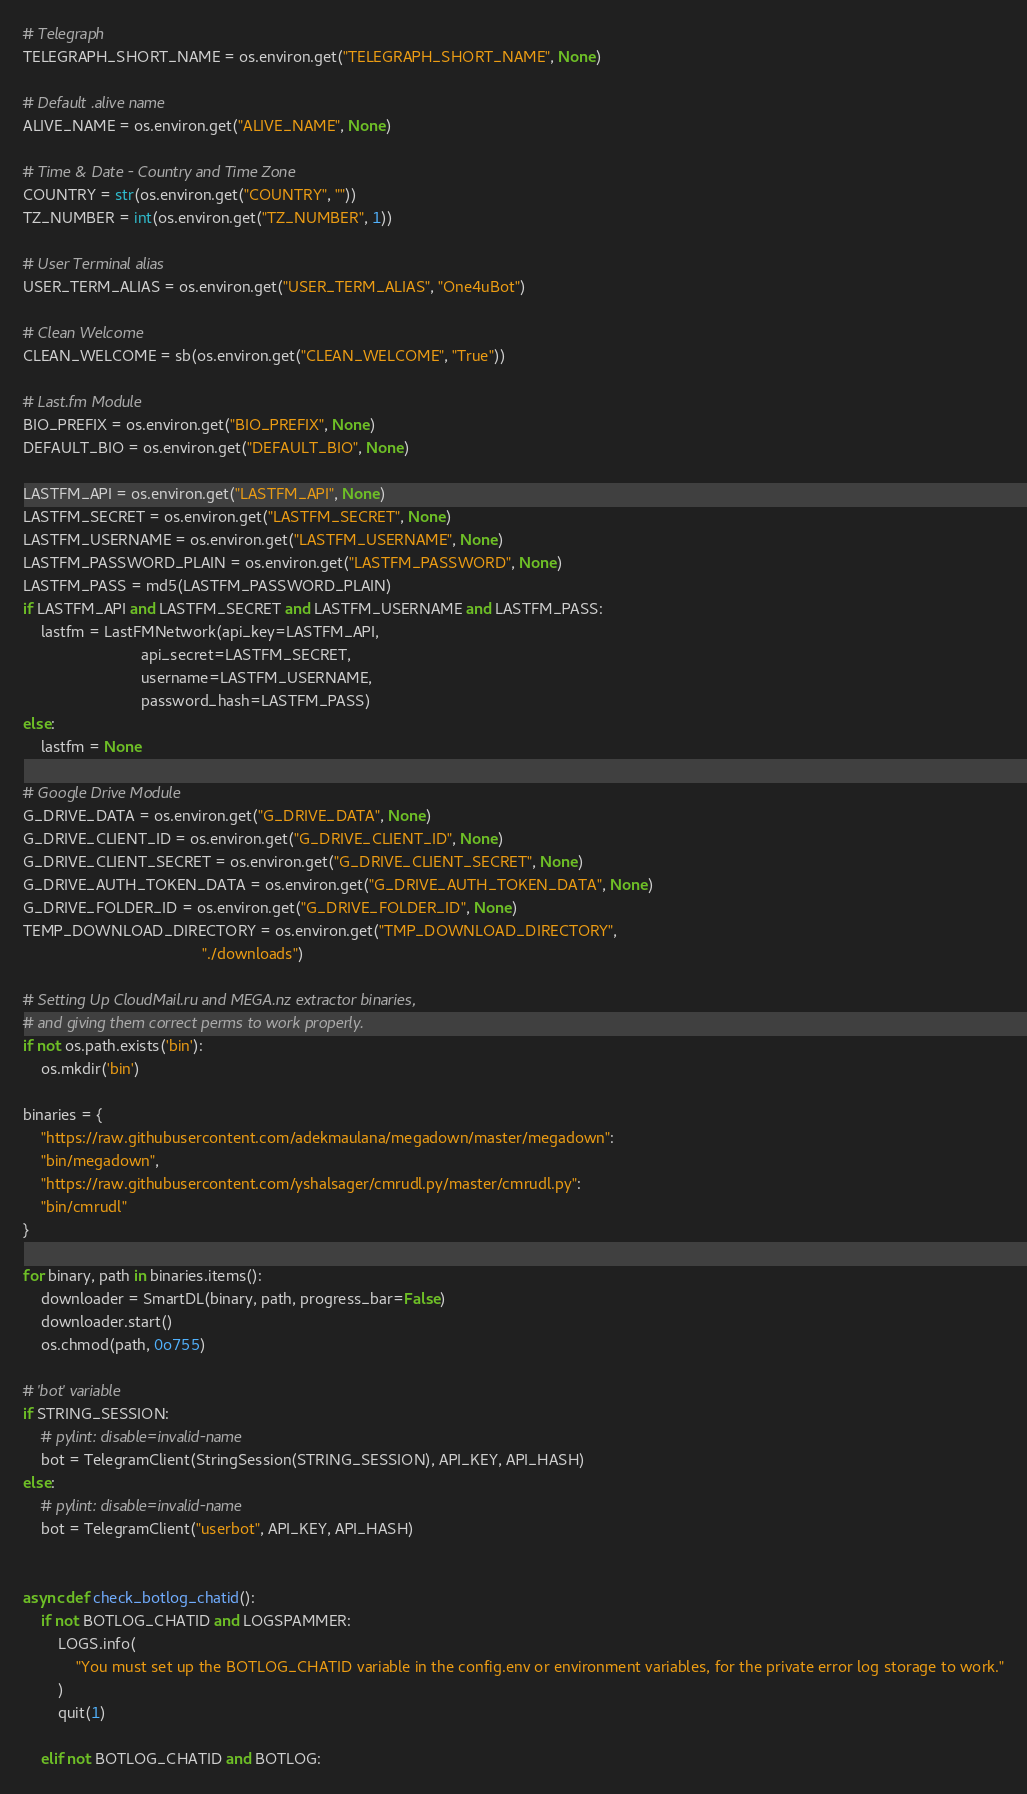Convert code to text. <code><loc_0><loc_0><loc_500><loc_500><_Python_># Telegraph 
TELEGRAPH_SHORT_NAME = os.environ.get("TELEGRAPH_SHORT_NAME", None)

# Default .alive name
ALIVE_NAME = os.environ.get("ALIVE_NAME", None)

# Time & Date - Country and Time Zone
COUNTRY = str(os.environ.get("COUNTRY", ""))
TZ_NUMBER = int(os.environ.get("TZ_NUMBER", 1))

# User Terminal alias
USER_TERM_ALIAS = os.environ.get("USER_TERM_ALIAS", "One4uBot")

# Clean Welcome
CLEAN_WELCOME = sb(os.environ.get("CLEAN_WELCOME", "True"))

# Last.fm Module
BIO_PREFIX = os.environ.get("BIO_PREFIX", None)
DEFAULT_BIO = os.environ.get("DEFAULT_BIO", None)

LASTFM_API = os.environ.get("LASTFM_API", None)
LASTFM_SECRET = os.environ.get("LASTFM_SECRET", None)
LASTFM_USERNAME = os.environ.get("LASTFM_USERNAME", None)
LASTFM_PASSWORD_PLAIN = os.environ.get("LASTFM_PASSWORD", None)
LASTFM_PASS = md5(LASTFM_PASSWORD_PLAIN)
if LASTFM_API and LASTFM_SECRET and LASTFM_USERNAME and LASTFM_PASS:
    lastfm = LastFMNetwork(api_key=LASTFM_API,
                           api_secret=LASTFM_SECRET,
                           username=LASTFM_USERNAME,
                           password_hash=LASTFM_PASS)
else:
    lastfm = None

# Google Drive Module
G_DRIVE_DATA = os.environ.get("G_DRIVE_DATA", None)
G_DRIVE_CLIENT_ID = os.environ.get("G_DRIVE_CLIENT_ID", None)
G_DRIVE_CLIENT_SECRET = os.environ.get("G_DRIVE_CLIENT_SECRET", None)
G_DRIVE_AUTH_TOKEN_DATA = os.environ.get("G_DRIVE_AUTH_TOKEN_DATA", None)
G_DRIVE_FOLDER_ID = os.environ.get("G_DRIVE_FOLDER_ID", None)
TEMP_DOWNLOAD_DIRECTORY = os.environ.get("TMP_DOWNLOAD_DIRECTORY",
                                         "./downloads")

# Setting Up CloudMail.ru and MEGA.nz extractor binaries,
# and giving them correct perms to work properly.
if not os.path.exists('bin'):
    os.mkdir('bin')

binaries = {
    "https://raw.githubusercontent.com/adekmaulana/megadown/master/megadown":
    "bin/megadown",
    "https://raw.githubusercontent.com/yshalsager/cmrudl.py/master/cmrudl.py":
    "bin/cmrudl"
}

for binary, path in binaries.items():
    downloader = SmartDL(binary, path, progress_bar=False)
    downloader.start()
    os.chmod(path, 0o755)

# 'bot' variable
if STRING_SESSION:
    # pylint: disable=invalid-name
    bot = TelegramClient(StringSession(STRING_SESSION), API_KEY, API_HASH)
else:
    # pylint: disable=invalid-name
    bot = TelegramClient("userbot", API_KEY, API_HASH)


async def check_botlog_chatid():
    if not BOTLOG_CHATID and LOGSPAMMER:
        LOGS.info(
            "You must set up the BOTLOG_CHATID variable in the config.env or environment variables, for the private error log storage to work."
        )
        quit(1)

    elif not BOTLOG_CHATID and BOTLOG:</code> 